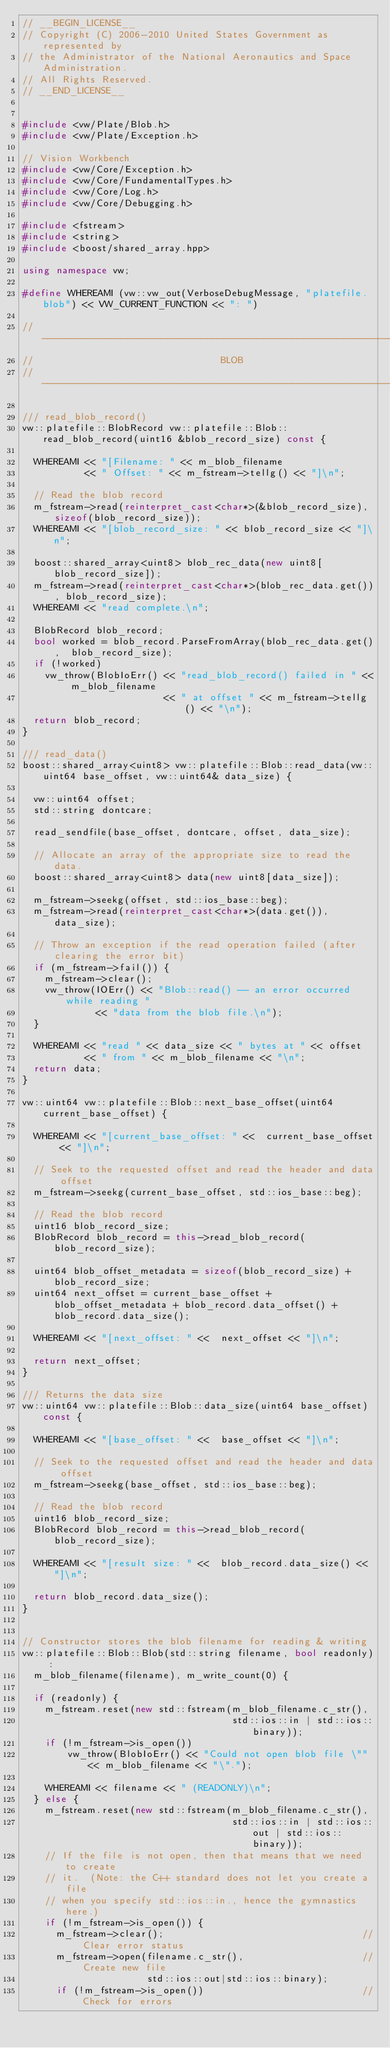<code> <loc_0><loc_0><loc_500><loc_500><_C++_>// __BEGIN_LICENSE__
// Copyright (C) 2006-2010 United States Government as represented by
// the Administrator of the National Aeronautics and Space Administration.
// All Rights Reserved.
// __END_LICENSE__


#include <vw/Plate/Blob.h>
#include <vw/Plate/Exception.h>

// Vision Workbench
#include <vw/Core/Exception.h>
#include <vw/Core/FundamentalTypes.h>
#include <vw/Core/Log.h>
#include <vw/Core/Debugging.h>

#include <fstream>
#include <string>
#include <boost/shared_array.hpp>

using namespace vw;

#define WHEREAMI (vw::vw_out(VerboseDebugMessage, "platefile.blob") << VW_CURRENT_FUNCTION << ": ")

// -------------------------------------------------------------------
//                                 BLOB
// -------------------------------------------------------------------

/// read_blob_record()
vw::platefile::BlobRecord vw::platefile::Blob::read_blob_record(uint16 &blob_record_size) const {

  WHEREAMI << "[Filename: " << m_blob_filename
           << " Offset: " << m_fstream->tellg() << "]\n";

  // Read the blob record
  m_fstream->read(reinterpret_cast<char*>(&blob_record_size), sizeof(blob_record_size));
  WHEREAMI << "[blob_record_size: " << blob_record_size << "]\n";

  boost::shared_array<uint8> blob_rec_data(new uint8[blob_record_size]);
  m_fstream->read(reinterpret_cast<char*>(blob_rec_data.get()), blob_record_size);
  WHEREAMI << "read complete.\n";

  BlobRecord blob_record;
  bool worked = blob_record.ParseFromArray(blob_rec_data.get(),  blob_record_size);
  if (!worked)
    vw_throw(BlobIoErr() << "read_blob_record() failed in " << m_blob_filename
                         << " at offset " << m_fstream->tellg() << "\n");
  return blob_record;
}

/// read_data()
boost::shared_array<uint8> vw::platefile::Blob::read_data(vw::uint64 base_offset, vw::uint64& data_size) {

  vw::uint64 offset;
  std::string dontcare;

  read_sendfile(base_offset, dontcare, offset, data_size);

  // Allocate an array of the appropriate size to read the data.
  boost::shared_array<uint8> data(new uint8[data_size]);

  m_fstream->seekg(offset, std::ios_base::beg);
  m_fstream->read(reinterpret_cast<char*>(data.get()), data_size);

  // Throw an exception if the read operation failed (after clearing the error bit)
  if (m_fstream->fail()) {
    m_fstream->clear();
    vw_throw(IOErr() << "Blob::read() -- an error occurred while reading "
             << "data from the blob file.\n");
  }

  WHEREAMI << "read " << data_size << " bytes at " << offset
           << " from " << m_blob_filename << "\n";
  return data;
}

vw::uint64 vw::platefile::Blob::next_base_offset(uint64 current_base_offset) {

  WHEREAMI << "[current_base_offset: " <<  current_base_offset << "]\n";

  // Seek to the requested offset and read the header and data offset
  m_fstream->seekg(current_base_offset, std::ios_base::beg);

  // Read the blob record
  uint16 blob_record_size;
  BlobRecord blob_record = this->read_blob_record(blob_record_size);

  uint64 blob_offset_metadata = sizeof(blob_record_size) + blob_record_size;
  uint64 next_offset = current_base_offset + blob_offset_metadata + blob_record.data_offset() + blob_record.data_size();

  WHEREAMI << "[next_offset: " <<  next_offset << "]\n";

  return next_offset;
}

/// Returns the data size
vw::uint64 vw::platefile::Blob::data_size(uint64 base_offset) const {

  WHEREAMI << "[base_offset: " <<  base_offset << "]\n";

  // Seek to the requested offset and read the header and data offset
  m_fstream->seekg(base_offset, std::ios_base::beg);

  // Read the blob record
  uint16 blob_record_size;
  BlobRecord blob_record = this->read_blob_record(blob_record_size);

  WHEREAMI << "[result size: " <<  blob_record.data_size() << "]\n";

  return blob_record.data_size();
}


// Constructor stores the blob filename for reading & writing
vw::platefile::Blob::Blob(std::string filename, bool readonly) :
  m_blob_filename(filename), m_write_count(0) {

  if (readonly) {
    m_fstream.reset(new std::fstream(m_blob_filename.c_str(),
                                     std::ios::in | std::ios::binary));
    if (!m_fstream->is_open())
        vw_throw(BlobIoErr() << "Could not open blob file \"" << m_blob_filename << "\".");

    WHEREAMI << filename << " (READONLY)\n";
  } else {
    m_fstream.reset(new std::fstream(m_blob_filename.c_str(),
                                     std::ios::in | std::ios::out | std::ios::binary));
    // If the file is not open, then that means that we need to create
    // it.  (Note: the C++ standard does not let you create a file
    // when you specify std::ios::in., hence the gymnastics here.)
    if (!m_fstream->is_open()) {
      m_fstream->clear();                                   // Clear error status
      m_fstream->open(filename.c_str(),                     // Create new file
                      std::ios::out|std::ios::binary);
      if (!m_fstream->is_open())                            // Check for errors</code> 